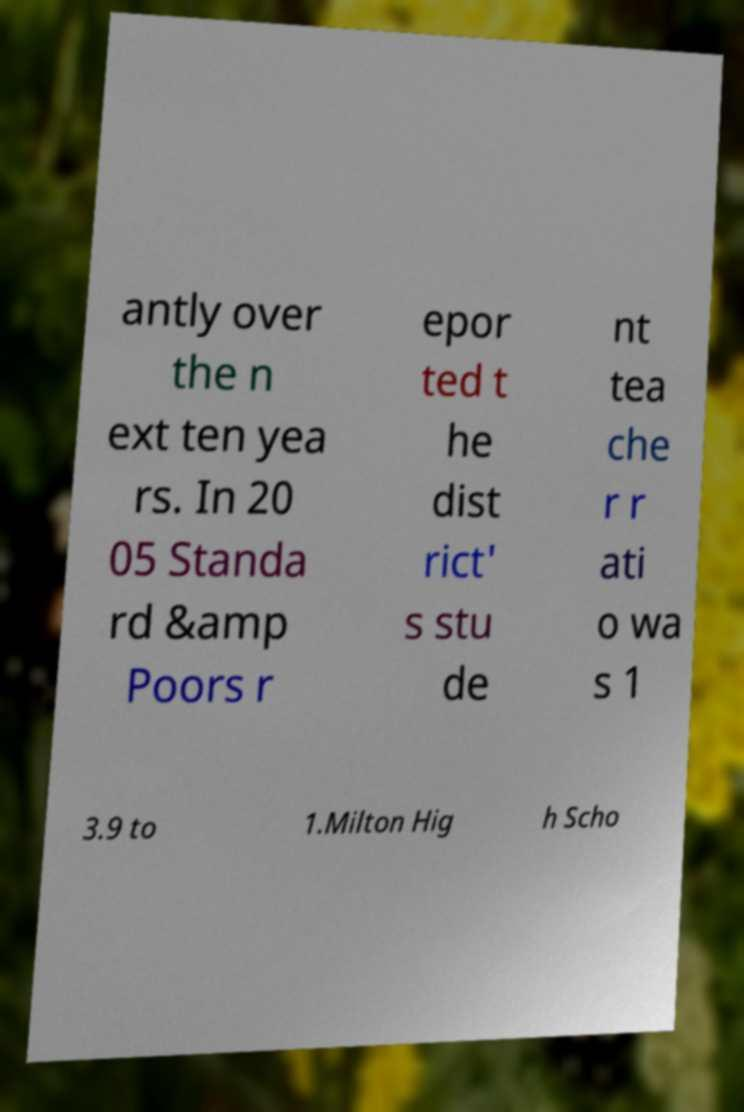Could you assist in decoding the text presented in this image and type it out clearly? antly over the n ext ten yea rs. In 20 05 Standa rd &amp Poors r epor ted t he dist rict' s stu de nt tea che r r ati o wa s 1 3.9 to 1.Milton Hig h Scho 